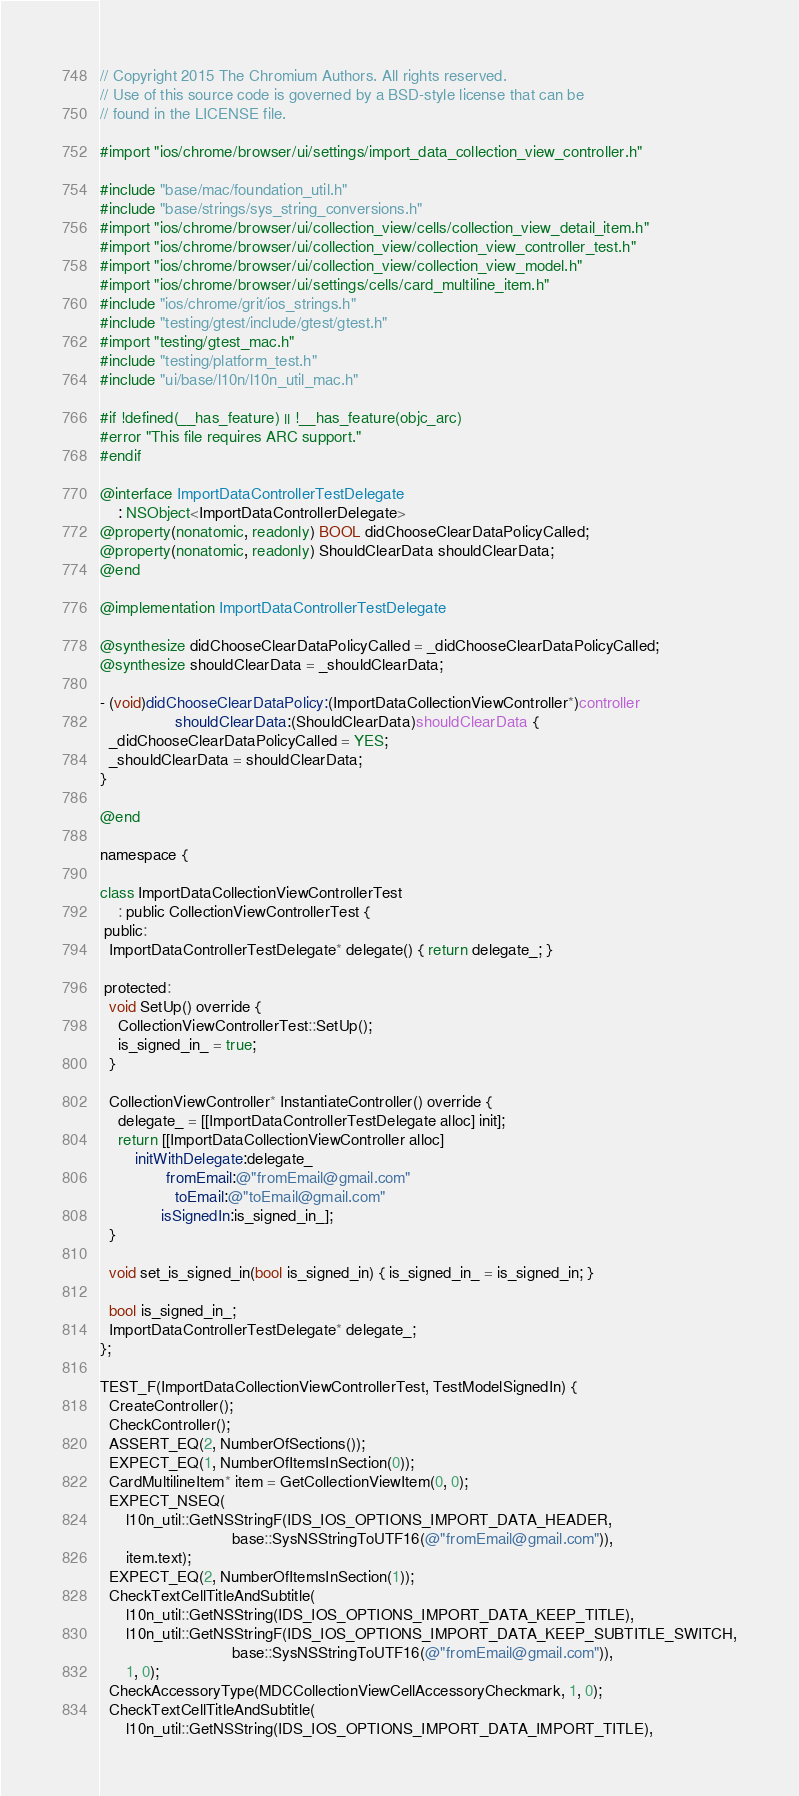Convert code to text. <code><loc_0><loc_0><loc_500><loc_500><_ObjectiveC_>// Copyright 2015 The Chromium Authors. All rights reserved.
// Use of this source code is governed by a BSD-style license that can be
// found in the LICENSE file.

#import "ios/chrome/browser/ui/settings/import_data_collection_view_controller.h"

#include "base/mac/foundation_util.h"
#include "base/strings/sys_string_conversions.h"
#import "ios/chrome/browser/ui/collection_view/cells/collection_view_detail_item.h"
#import "ios/chrome/browser/ui/collection_view/collection_view_controller_test.h"
#import "ios/chrome/browser/ui/collection_view/collection_view_model.h"
#import "ios/chrome/browser/ui/settings/cells/card_multiline_item.h"
#include "ios/chrome/grit/ios_strings.h"
#include "testing/gtest/include/gtest/gtest.h"
#import "testing/gtest_mac.h"
#include "testing/platform_test.h"
#include "ui/base/l10n/l10n_util_mac.h"

#if !defined(__has_feature) || !__has_feature(objc_arc)
#error "This file requires ARC support."
#endif

@interface ImportDataControllerTestDelegate
    : NSObject<ImportDataControllerDelegate>
@property(nonatomic, readonly) BOOL didChooseClearDataPolicyCalled;
@property(nonatomic, readonly) ShouldClearData shouldClearData;
@end

@implementation ImportDataControllerTestDelegate

@synthesize didChooseClearDataPolicyCalled = _didChooseClearDataPolicyCalled;
@synthesize shouldClearData = _shouldClearData;

- (void)didChooseClearDataPolicy:(ImportDataCollectionViewController*)controller
                 shouldClearData:(ShouldClearData)shouldClearData {
  _didChooseClearDataPolicyCalled = YES;
  _shouldClearData = shouldClearData;
}

@end

namespace {

class ImportDataCollectionViewControllerTest
    : public CollectionViewControllerTest {
 public:
  ImportDataControllerTestDelegate* delegate() { return delegate_; }

 protected:
  void SetUp() override {
    CollectionViewControllerTest::SetUp();
    is_signed_in_ = true;
  }

  CollectionViewController* InstantiateController() override {
    delegate_ = [[ImportDataControllerTestDelegate alloc] init];
    return [[ImportDataCollectionViewController alloc]
        initWithDelegate:delegate_
               fromEmail:@"fromEmail@gmail.com"
                 toEmail:@"toEmail@gmail.com"
              isSignedIn:is_signed_in_];
  }

  void set_is_signed_in(bool is_signed_in) { is_signed_in_ = is_signed_in; }

  bool is_signed_in_;
  ImportDataControllerTestDelegate* delegate_;
};

TEST_F(ImportDataCollectionViewControllerTest, TestModelSignedIn) {
  CreateController();
  CheckController();
  ASSERT_EQ(2, NumberOfSections());
  EXPECT_EQ(1, NumberOfItemsInSection(0));
  CardMultilineItem* item = GetCollectionViewItem(0, 0);
  EXPECT_NSEQ(
      l10n_util::GetNSStringF(IDS_IOS_OPTIONS_IMPORT_DATA_HEADER,
                              base::SysNSStringToUTF16(@"fromEmail@gmail.com")),
      item.text);
  EXPECT_EQ(2, NumberOfItemsInSection(1));
  CheckTextCellTitleAndSubtitle(
      l10n_util::GetNSString(IDS_IOS_OPTIONS_IMPORT_DATA_KEEP_TITLE),
      l10n_util::GetNSStringF(IDS_IOS_OPTIONS_IMPORT_DATA_KEEP_SUBTITLE_SWITCH,
                              base::SysNSStringToUTF16(@"fromEmail@gmail.com")),
      1, 0);
  CheckAccessoryType(MDCCollectionViewCellAccessoryCheckmark, 1, 0);
  CheckTextCellTitleAndSubtitle(
      l10n_util::GetNSString(IDS_IOS_OPTIONS_IMPORT_DATA_IMPORT_TITLE),</code> 